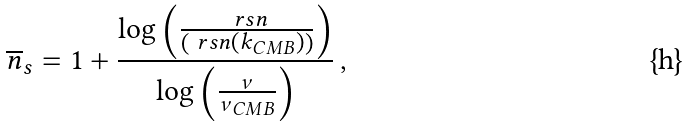Convert formula to latex. <formula><loc_0><loc_0><loc_500><loc_500>\overline { n } _ { s } = 1 + \frac { \log \left ( \frac { \ r s n } { \left ( \ r s n ( k _ { C M B } ) \right ) } \right ) } { \log \left ( \frac { \nu } { \nu _ { C M B } } \right ) } \, ,</formula> 